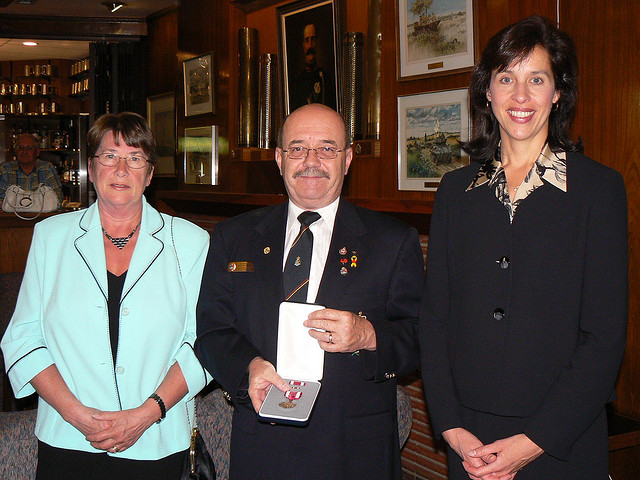What can you infer about the people in the photograph? The individuals in the photograph appear to be adults, likely participating in a special moment. The central figure is wearing multiple decorations, suggesting an accomplishment or recognition. They all have pleasant expressions, indicating a positive atmosphere. 